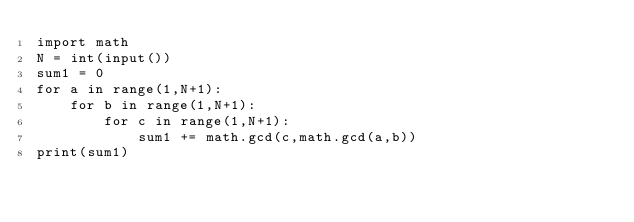<code> <loc_0><loc_0><loc_500><loc_500><_Python_>import math
N = int(input())
sum1 = 0
for a in range(1,N+1):
    for b in range(1,N+1):
        for c in range(1,N+1):
            sum1 += math.gcd(c,math.gcd(a,b))
print(sum1)</code> 